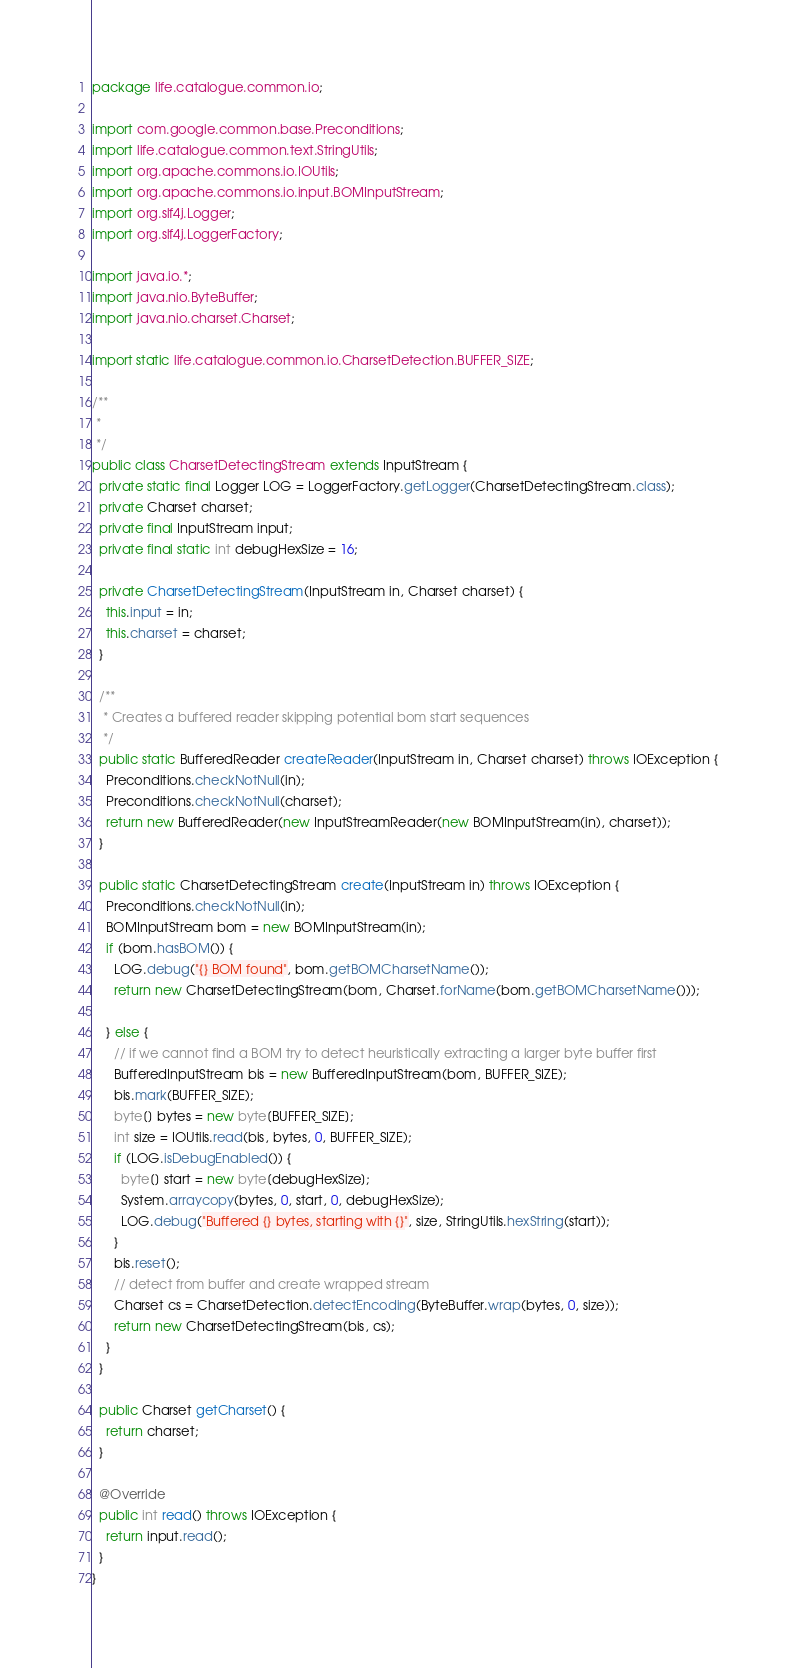Convert code to text. <code><loc_0><loc_0><loc_500><loc_500><_Java_>package life.catalogue.common.io;

import com.google.common.base.Preconditions;
import life.catalogue.common.text.StringUtils;
import org.apache.commons.io.IOUtils;
import org.apache.commons.io.input.BOMInputStream;
import org.slf4j.Logger;
import org.slf4j.LoggerFactory;

import java.io.*;
import java.nio.ByteBuffer;
import java.nio.charset.Charset;

import static life.catalogue.common.io.CharsetDetection.BUFFER_SIZE;

/**
 *
 */
public class CharsetDetectingStream extends InputStream {
  private static final Logger LOG = LoggerFactory.getLogger(CharsetDetectingStream.class);
  private Charset charset;
  private final InputStream input;
  private final static int debugHexSize = 16;
  
  private CharsetDetectingStream(InputStream in, Charset charset) {
    this.input = in;
    this.charset = charset;
  }
  
  /**
   * Creates a buffered reader skipping potential bom start sequences
   */
  public static BufferedReader createReader(InputStream in, Charset charset) throws IOException {
    Preconditions.checkNotNull(in);
    Preconditions.checkNotNull(charset);
    return new BufferedReader(new InputStreamReader(new BOMInputStream(in), charset));
  }
  
  public static CharsetDetectingStream create(InputStream in) throws IOException {
    Preconditions.checkNotNull(in);
    BOMInputStream bom = new BOMInputStream(in);
    if (bom.hasBOM()) {
      LOG.debug("{} BOM found", bom.getBOMCharsetName());
      return new CharsetDetectingStream(bom, Charset.forName(bom.getBOMCharsetName()));
      
    } else {
      // if we cannot find a BOM try to detect heuristically extracting a larger byte buffer first
      BufferedInputStream bis = new BufferedInputStream(bom, BUFFER_SIZE);
      bis.mark(BUFFER_SIZE);
      byte[] bytes = new byte[BUFFER_SIZE];
      int size = IOUtils.read(bis, bytes, 0, BUFFER_SIZE);
      if (LOG.isDebugEnabled()) {
        byte[] start = new byte[debugHexSize];
        System.arraycopy(bytes, 0, start, 0, debugHexSize);
        LOG.debug("Buffered {} bytes, starting with {}", size, StringUtils.hexString(start));
      }
      bis.reset();
      // detect from buffer and create wrapped stream
      Charset cs = CharsetDetection.detectEncoding(ByteBuffer.wrap(bytes, 0, size));
      return new CharsetDetectingStream(bis, cs);
    }
  }
  
  public Charset getCharset() {
    return charset;
  }
  
  @Override
  public int read() throws IOException {
    return input.read();
  }
}
</code> 